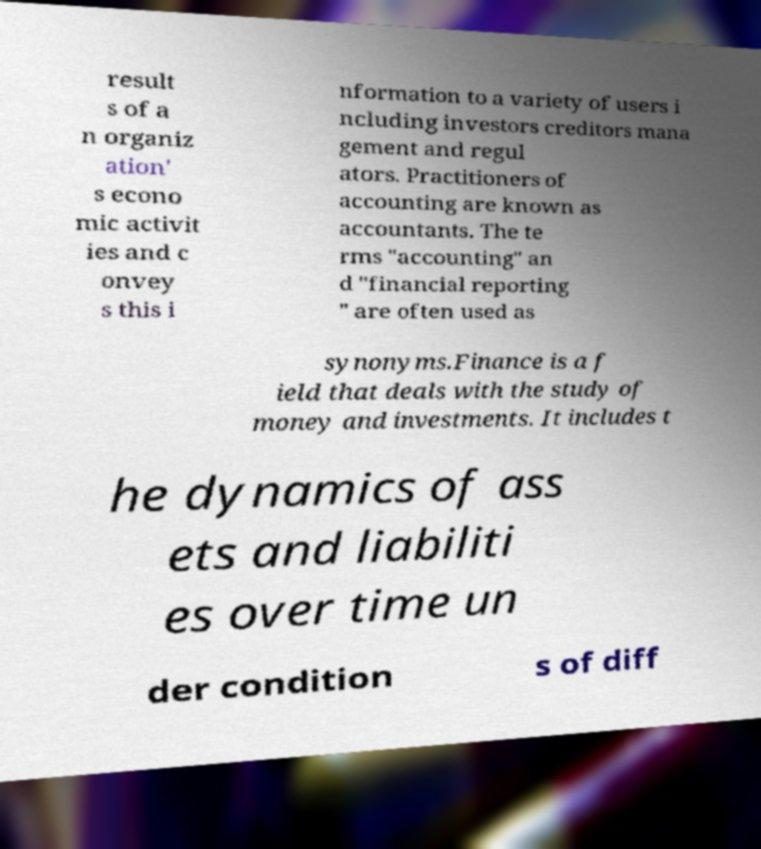I need the written content from this picture converted into text. Can you do that? result s of a n organiz ation' s econo mic activit ies and c onvey s this i nformation to a variety of users i ncluding investors creditors mana gement and regul ators. Practitioners of accounting are known as accountants. The te rms "accounting" an d "financial reporting " are often used as synonyms.Finance is a f ield that deals with the study of money and investments. It includes t he dynamics of ass ets and liabiliti es over time un der condition s of diff 